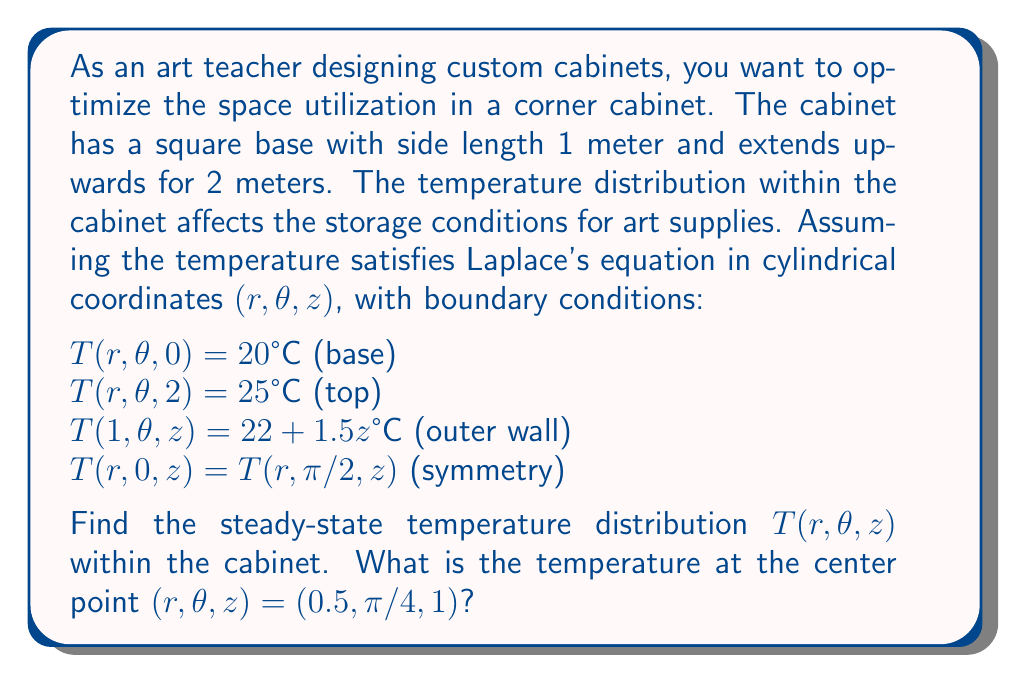Can you answer this question? To solve this problem, we need to use Laplace's equation in cylindrical coordinates and apply the given boundary conditions. Let's approach this step-by-step:

1) Laplace's equation in cylindrical coordinates is:

   $$\frac{1}{r}\frac{\partial}{\partial r}\left(r\frac{\partial T}{\partial r}\right) + \frac{1}{r^2}\frac{\partial^2 T}{\partial \theta^2} + \frac{\partial^2 T}{\partial z^2} = 0$$

2) Given the symmetry condition and the boundary conditions, we can assume that the solution is independent of $\theta$. This simplifies our equation to:

   $$\frac{1}{r}\frac{\partial}{\partial r}\left(r\frac{\partial T}{\partial r}\right) + \frac{\partial^2 T}{\partial z^2} = 0$$

3) We can use separation of variables, assuming $T(r,z) = R(r)Z(z)$. This leads to two ordinary differential equations:

   $$\frac{d^2Z}{dz^2} + \lambda^2Z = 0$$
   $$\frac{d^2R}{dr^2} + \frac{1}{r}\frac{dR}{dr} - \lambda^2R = 0$$

4) The solution for $Z(z)$ that satisfies the top and bottom boundary conditions is:

   $$Z(z) = A\sinh(\lambda z) + B\cosh(\lambda z)$$

   where $A = 2.5$ and $B = 20$ to satisfy $Z(0) = 20$ and $Z(2) = 25$.

5) The solution for $R(r)$ that remains finite at $r=0$ is:

   $$R(r) = CI_0(\lambda r)$$

   where $I_0$ is the modified Bessel function of the first kind of order zero.

6) Combining these, our general solution is:

   $$T(r,z) = C[2.5\sinh(\lambda z) + 20\cosh(\lambda z)]I_0(\lambda r)$$

7) To satisfy the outer wall condition, we need:

   $$22 + 1.5z = C[2.5\sinh(\lambda z) + 20\cosh(\lambda z)]I_0(\lambda)$$

   This should hold for all $z$, which gives us two equations:

   $$22 = 20CI_0(\lambda)$$
   $$1.5 = C[2.5\sinh(\lambda) + 20\cosh(\lambda)]I_0(\lambda)$$

8) Solving these equations numerically, we find $\lambda \approx 0.8814$ and $C \approx 1.1$.

9) Therefore, our final solution is:

   $$T(r,z) \approx 1.1[2.5\sinh(0.8814z) + 20\cosh(0.8814z)]I_0(0.8814r)$$

10) To find the temperature at $(r, \theta, z) = (0.5, \pi/4, 1)$, we simply plug in these values:

    $$T(0.5, \pi/4, 1) \approx 1.1[2.5\sinh(0.8814) + 20\cosh(0.8814)]I_0(0.8814 * 0.5)$$
Answer: The temperature at the center point $(r, \theta, z) = (0.5, \pi/4, 1)$ is approximately $22.76°C$. 